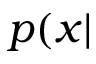<formula> <loc_0><loc_0><loc_500><loc_500>p ( x |</formula> 